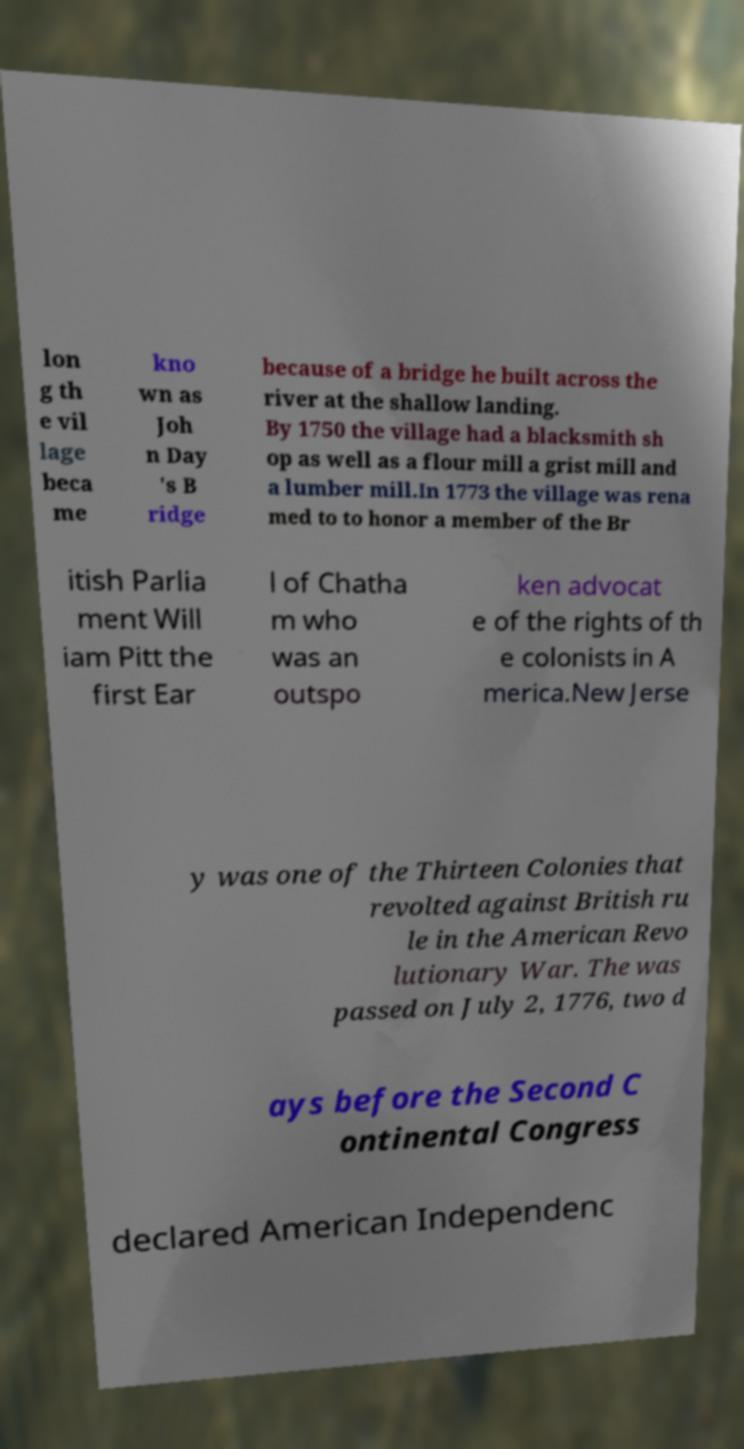Please identify and transcribe the text found in this image. lon g th e vil lage beca me kno wn as Joh n Day 's B ridge because of a bridge he built across the river at the shallow landing. By 1750 the village had a blacksmith sh op as well as a flour mill a grist mill and a lumber mill.In 1773 the village was rena med to to honor a member of the Br itish Parlia ment Will iam Pitt the first Ear l of Chatha m who was an outspo ken advocat e of the rights of th e colonists in A merica.New Jerse y was one of the Thirteen Colonies that revolted against British ru le in the American Revo lutionary War. The was passed on July 2, 1776, two d ays before the Second C ontinental Congress declared American Independenc 